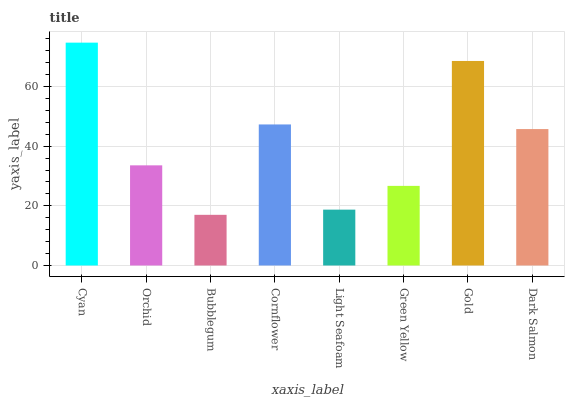Is Bubblegum the minimum?
Answer yes or no. Yes. Is Cyan the maximum?
Answer yes or no. Yes. Is Orchid the minimum?
Answer yes or no. No. Is Orchid the maximum?
Answer yes or no. No. Is Cyan greater than Orchid?
Answer yes or no. Yes. Is Orchid less than Cyan?
Answer yes or no. Yes. Is Orchid greater than Cyan?
Answer yes or no. No. Is Cyan less than Orchid?
Answer yes or no. No. Is Dark Salmon the high median?
Answer yes or no. Yes. Is Orchid the low median?
Answer yes or no. Yes. Is Green Yellow the high median?
Answer yes or no. No. Is Green Yellow the low median?
Answer yes or no. No. 